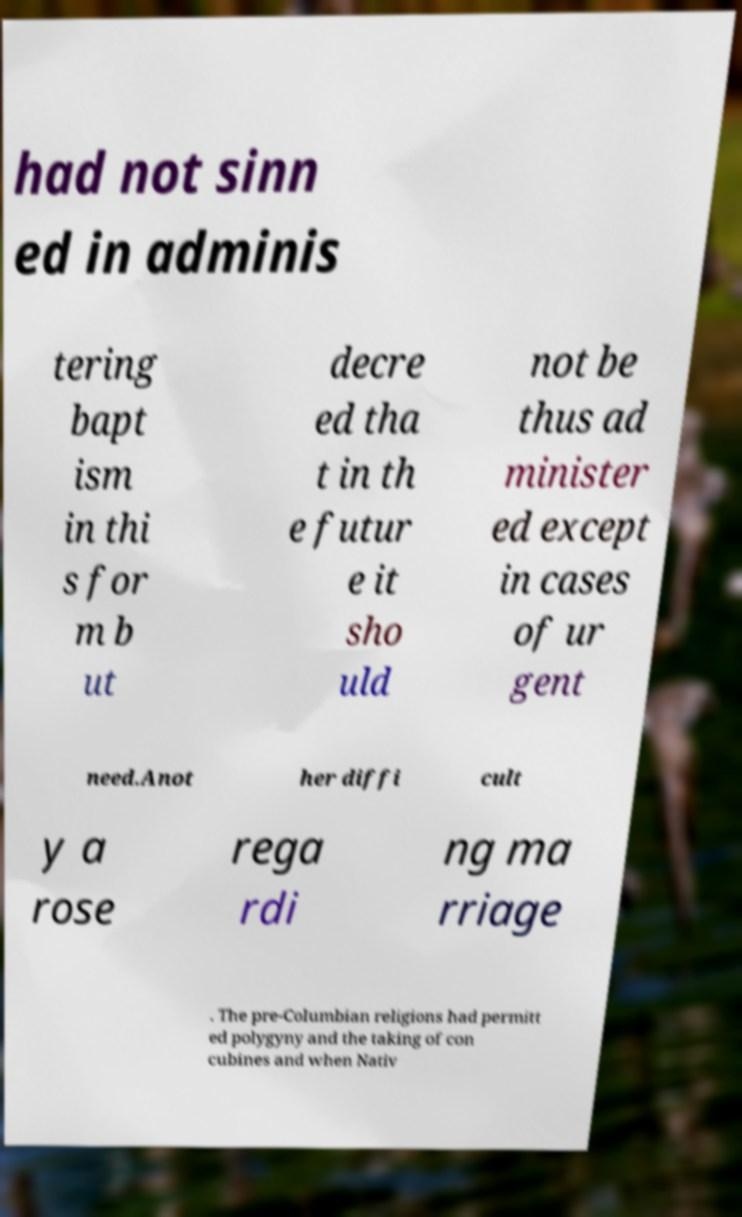There's text embedded in this image that I need extracted. Can you transcribe it verbatim? had not sinn ed in adminis tering bapt ism in thi s for m b ut decre ed tha t in th e futur e it sho uld not be thus ad minister ed except in cases of ur gent need.Anot her diffi cult y a rose rega rdi ng ma rriage . The pre-Columbian religions had permitt ed polygyny and the taking of con cubines and when Nativ 